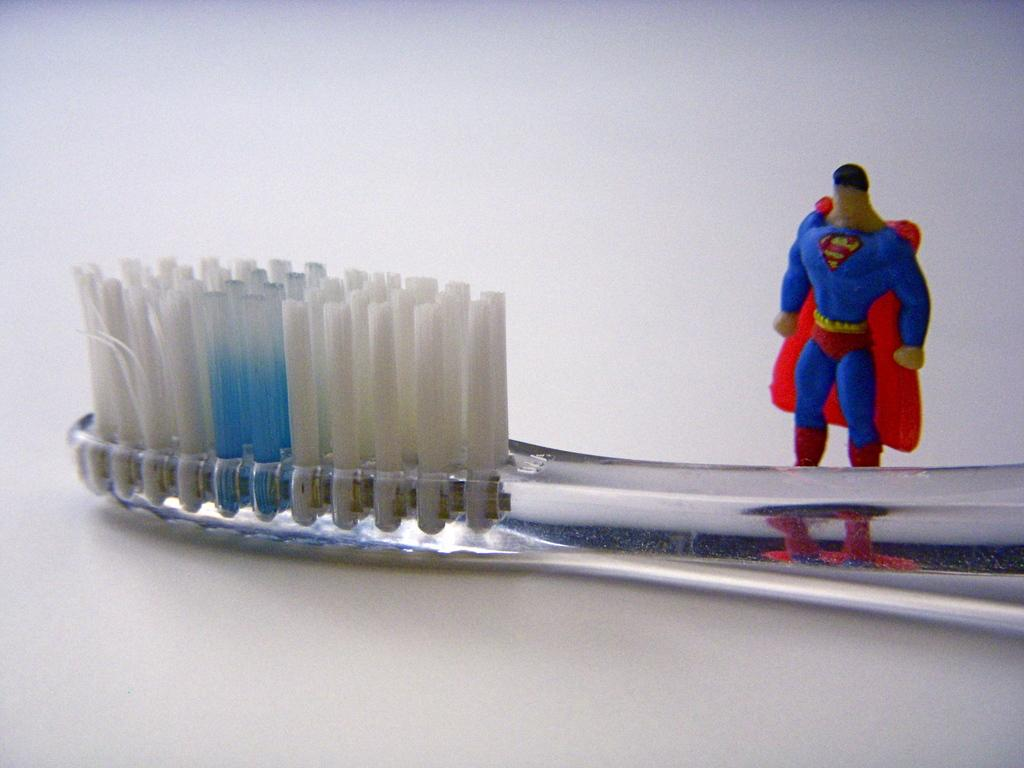What object in the image is typically used for play? There is a toy in the image, which is typically used for play. What object in the image is used for dental hygiene? There is a toothbrush in the image, which is used for dental hygiene. What color is the background of the image? The background of the image is white in color. How many chickens are visible in the image? There are no chickens present in the image. What type of note is attached to the toy in the image? There is no note attached to the toy in the image. 